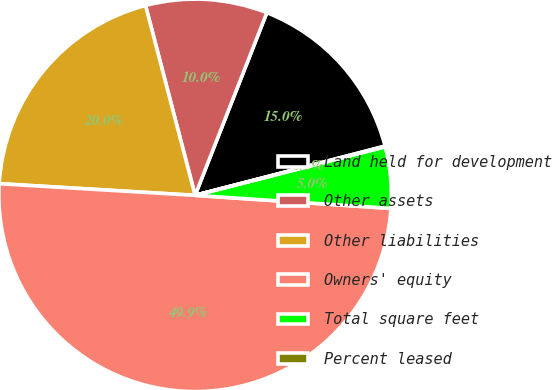Convert chart. <chart><loc_0><loc_0><loc_500><loc_500><pie_chart><fcel>Land held for development<fcel>Other assets<fcel>Other liabilities<fcel>Owners' equity<fcel>Total square feet<fcel>Percent leased<nl><fcel>15.01%<fcel>10.02%<fcel>19.99%<fcel>49.89%<fcel>5.04%<fcel>0.06%<nl></chart> 